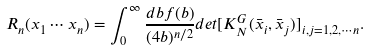Convert formula to latex. <formula><loc_0><loc_0><loc_500><loc_500>R _ { n } ( x _ { 1 } \cdots x _ { n } ) = \int _ { 0 } ^ { \infty } \frac { d b f ( b ) } { ( 4 b ) ^ { n / 2 } } d e t [ K ^ { G } _ { N } ( \bar { x } _ { i } , \bar { x } _ { j } ) ] _ { i , j = 1 , 2 , \cdots n } .</formula> 